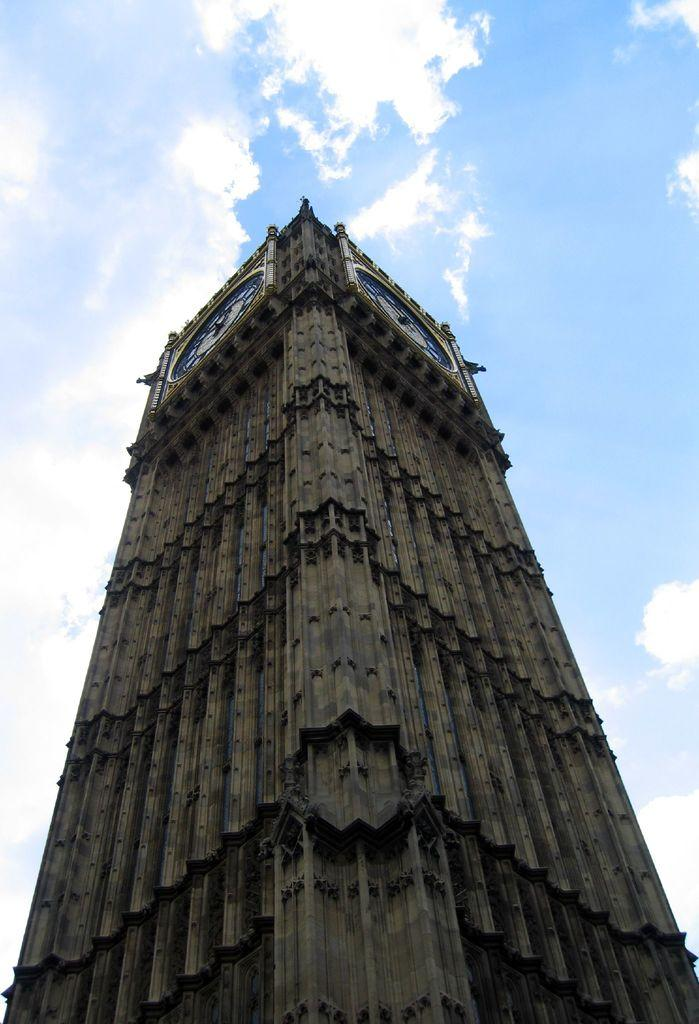What is the main subject in the foreground of the image? There is a tower in the foreground of the image. What can be seen at the top of the tower? The sky is visible at the top of the tower. What type of cake is being served at the top of the tower in the image? There is no cake present in the image; it only features a tower with the sky visible at the top. 